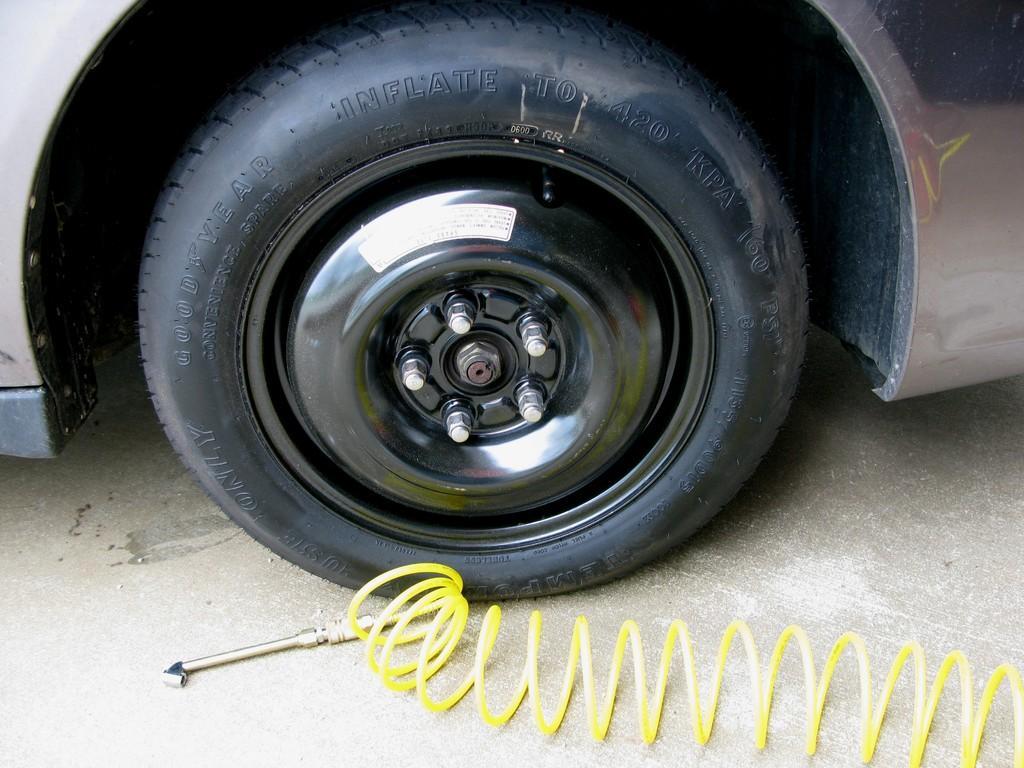Describe this image in one or two sentences. In this image we can see a vehicle. At the bottom there is a tool and we can see a spring. 